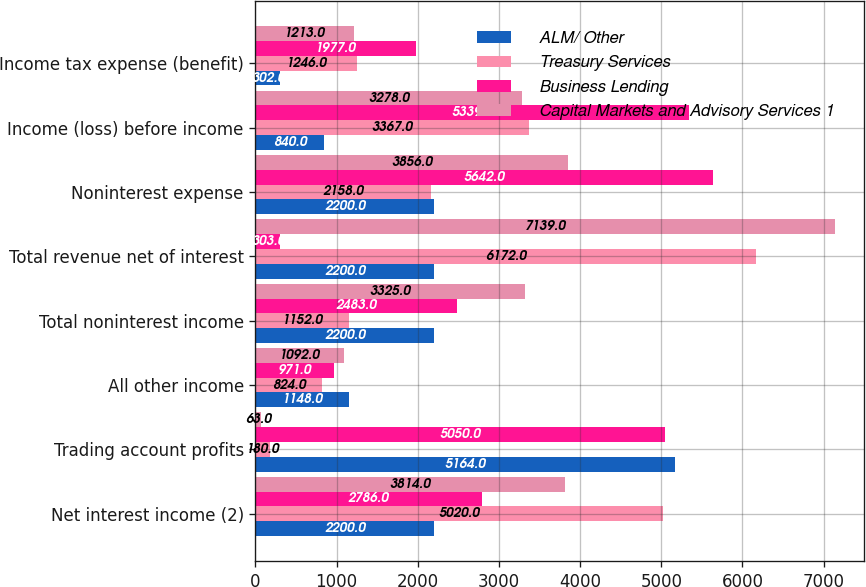<chart> <loc_0><loc_0><loc_500><loc_500><stacked_bar_chart><ecel><fcel>Net interest income (2)<fcel>Trading account profits<fcel>All other income<fcel>Total noninterest income<fcel>Total revenue net of interest<fcel>Noninterest expense<fcel>Income (loss) before income<fcel>Income tax expense (benefit)<nl><fcel>ALM/ Other<fcel>2200<fcel>5164<fcel>1148<fcel>2200<fcel>2200<fcel>2200<fcel>840<fcel>302<nl><fcel>Treasury Services<fcel>5020<fcel>180<fcel>824<fcel>1152<fcel>6172<fcel>2158<fcel>3367<fcel>1246<nl><fcel>Business Lending<fcel>2786<fcel>5050<fcel>971<fcel>2483<fcel>303<fcel>5642<fcel>5339<fcel>1977<nl><fcel>Capital Markets and Advisory Services 1<fcel>3814<fcel>63<fcel>1092<fcel>3325<fcel>7139<fcel>3856<fcel>3278<fcel>1213<nl></chart> 